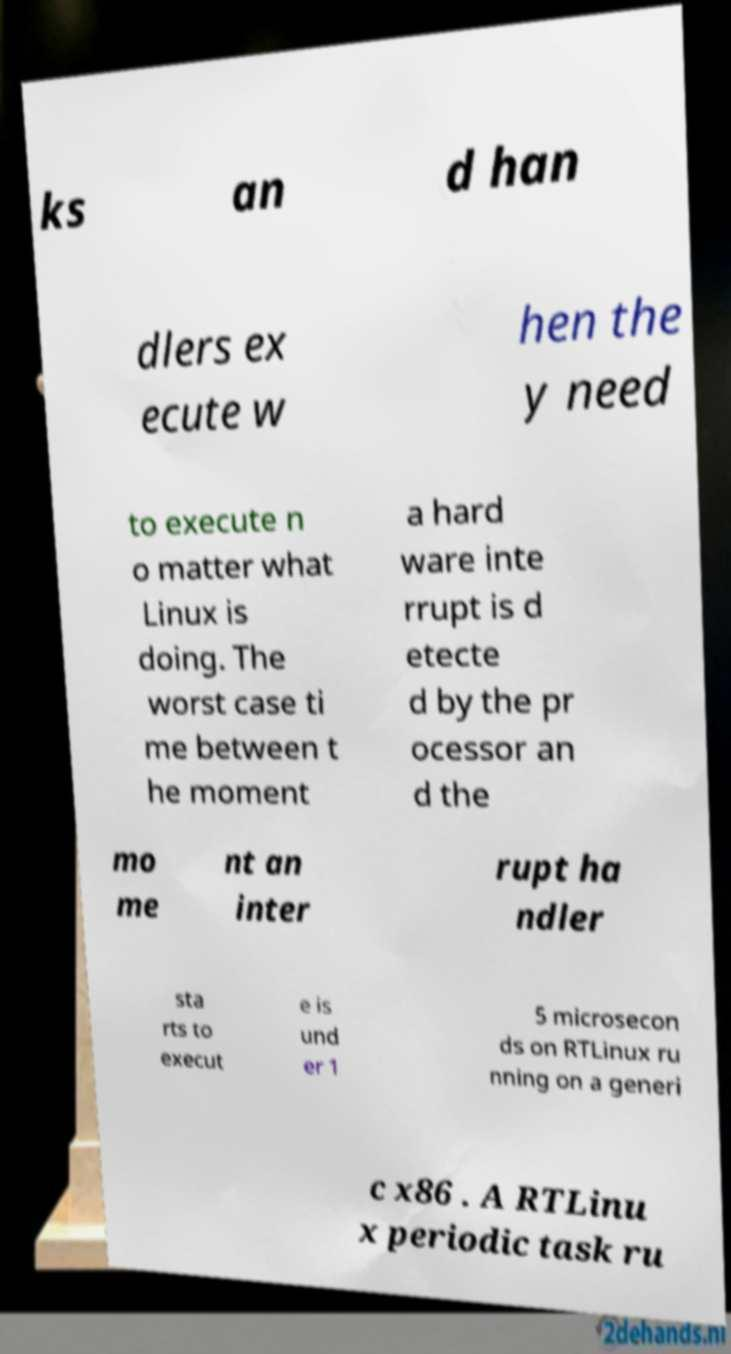What messages or text are displayed in this image? I need them in a readable, typed format. ks an d han dlers ex ecute w hen the y need to execute n o matter what Linux is doing. The worst case ti me between t he moment a hard ware inte rrupt is d etecte d by the pr ocessor an d the mo me nt an inter rupt ha ndler sta rts to execut e is und er 1 5 microsecon ds on RTLinux ru nning on a generi c x86 . A RTLinu x periodic task ru 